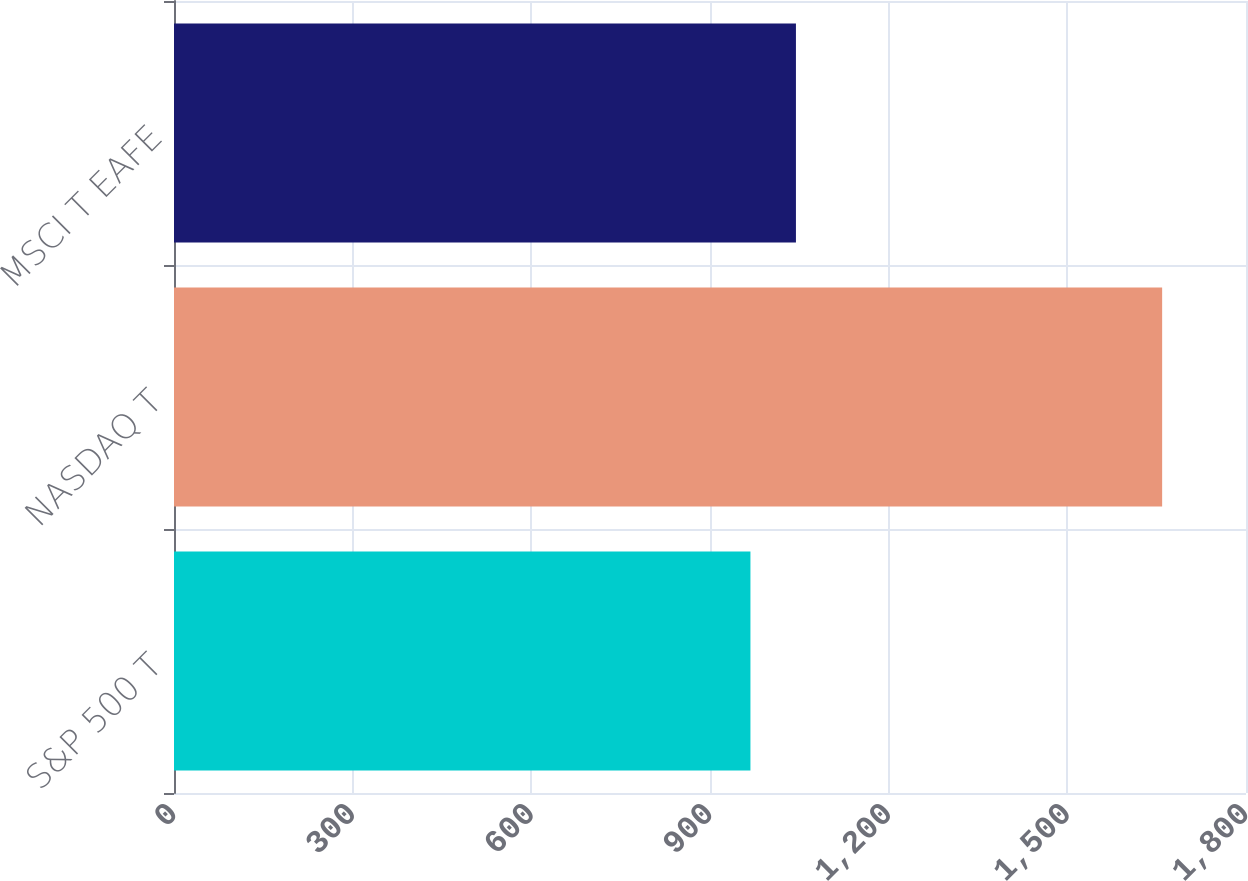Convert chart to OTSL. <chart><loc_0><loc_0><loc_500><loc_500><bar_chart><fcel>S&P 500 T<fcel>NASDAQ T<fcel>MSCI T EAFE<nl><fcel>967.9<fcel>1659.2<fcel>1044.3<nl></chart> 